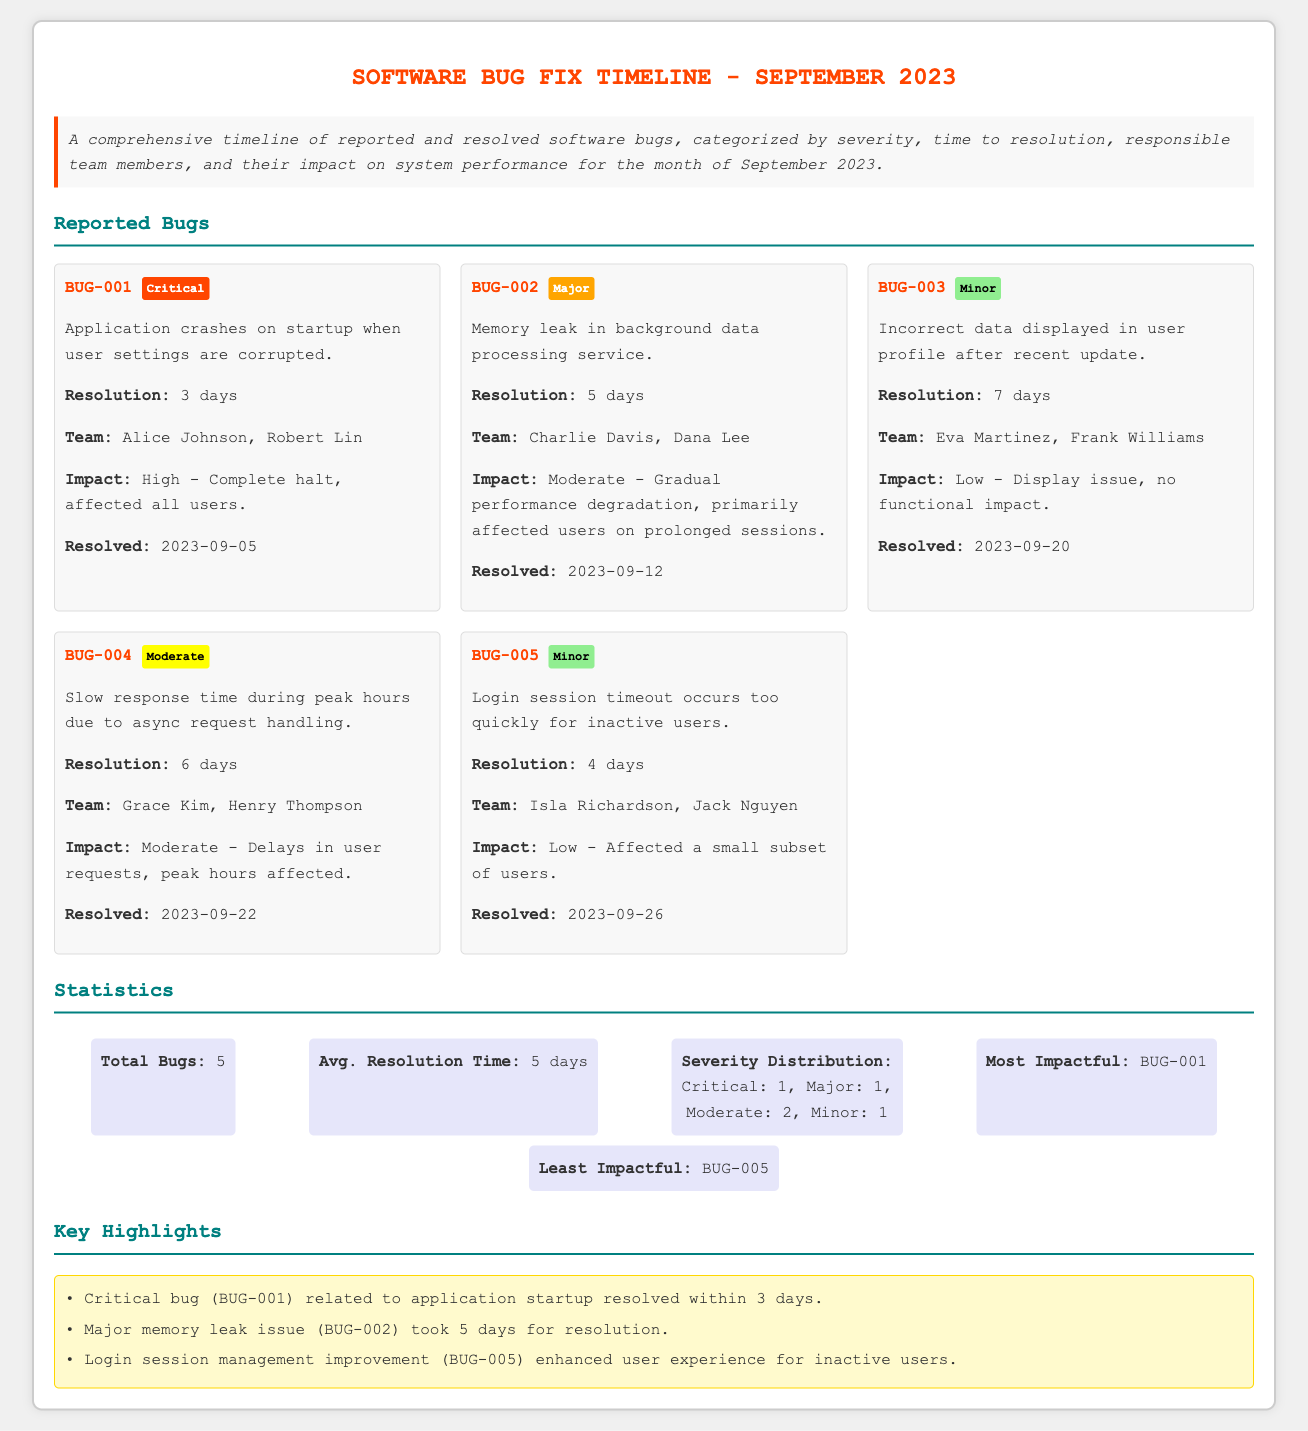What is the total number of reported bugs? The total number of reported bugs is listed in the statistics section of the document, which states that there are 5 bugs.
Answer: 5 What is the severity level of BUG-002? The severity level of BUG-002 is categorized in the document under the bug details, which states it is a Major bug.
Answer: Major Who are the team members responsible for resolving BUG-001? The team members responsible for resolving BUG-001 are mentioned in the bug details, which lists Alice Johnson and Robert Lin.
Answer: Alice Johnson, Robert Lin How long did it take to resolve the slow response time issue (BUG-004)? The resolution time for the slow response time issue is specified in the bug details, which states it took 6 days.
Answer: 6 days What is the impact of the memory leak issue (BUG-002)? The impact of the memory leak issue is described in the bug details, which mentions it as Moderate - Gradual performance degradation.
Answer: Moderate - Gradual performance degradation Which bug had the most impact? The bug with the most impact is highlighted in the statistics section, noting that it is BUG-001.
Answer: BUG-001 What was the average resolution time for bugs? The average resolution time for bugs is indicated in the statistics section, which states it is 5 days.
Answer: 5 days How many critical bugs were reported? The severity distribution in the statistics section indicates that 1 Critical bug was reported.
Answer: 1 What is the date when BUG-003 was resolved? The document states the resolution date for BUG-003 in the bug details, which is 2023-09-20.
Answer: 2023-09-20 